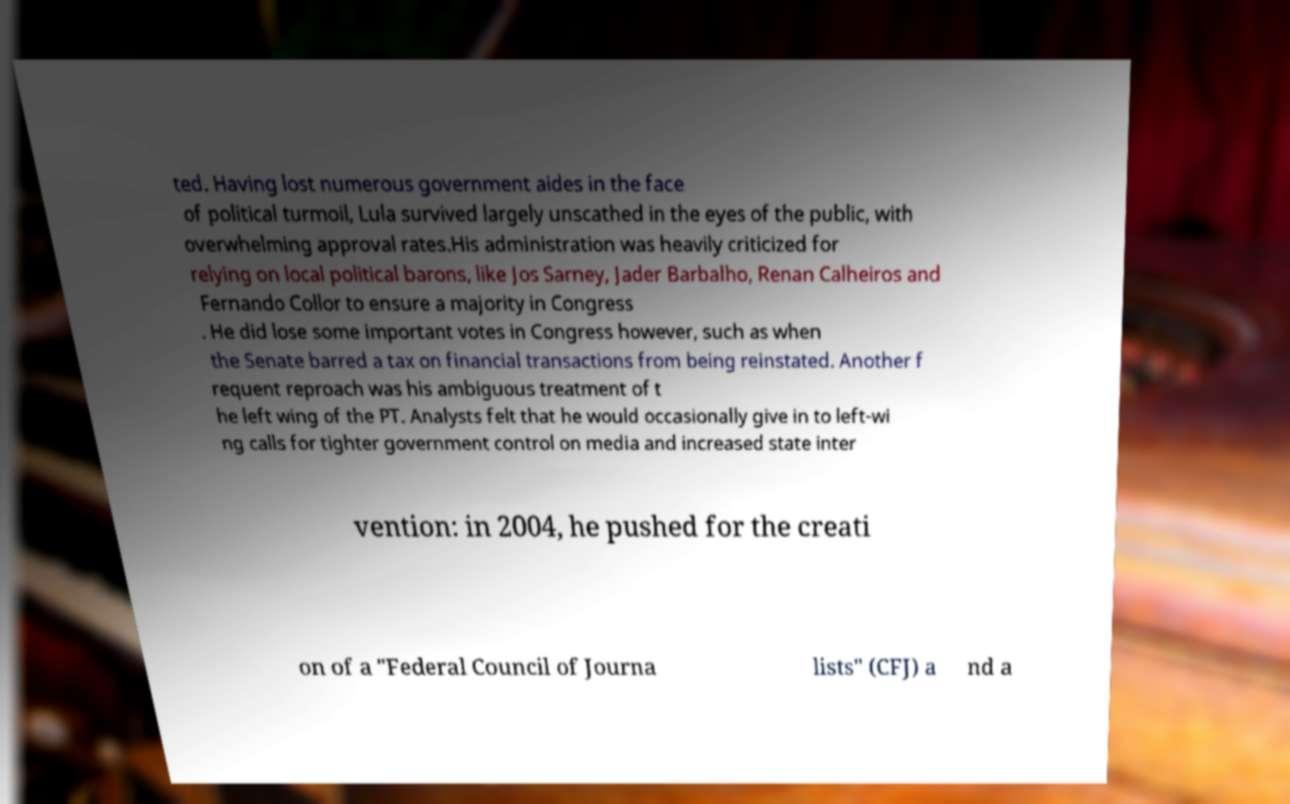Could you extract and type out the text from this image? ted. Having lost numerous government aides in the face of political turmoil, Lula survived largely unscathed in the eyes of the public, with overwhelming approval rates.His administration was heavily criticized for relying on local political barons, like Jos Sarney, Jader Barbalho, Renan Calheiros and Fernando Collor to ensure a majority in Congress . He did lose some important votes in Congress however, such as when the Senate barred a tax on financial transactions from being reinstated. Another f requent reproach was his ambiguous treatment of t he left wing of the PT. Analysts felt that he would occasionally give in to left-wi ng calls for tighter government control on media and increased state inter vention: in 2004, he pushed for the creati on of a "Federal Council of Journa lists" (CFJ) a nd a 